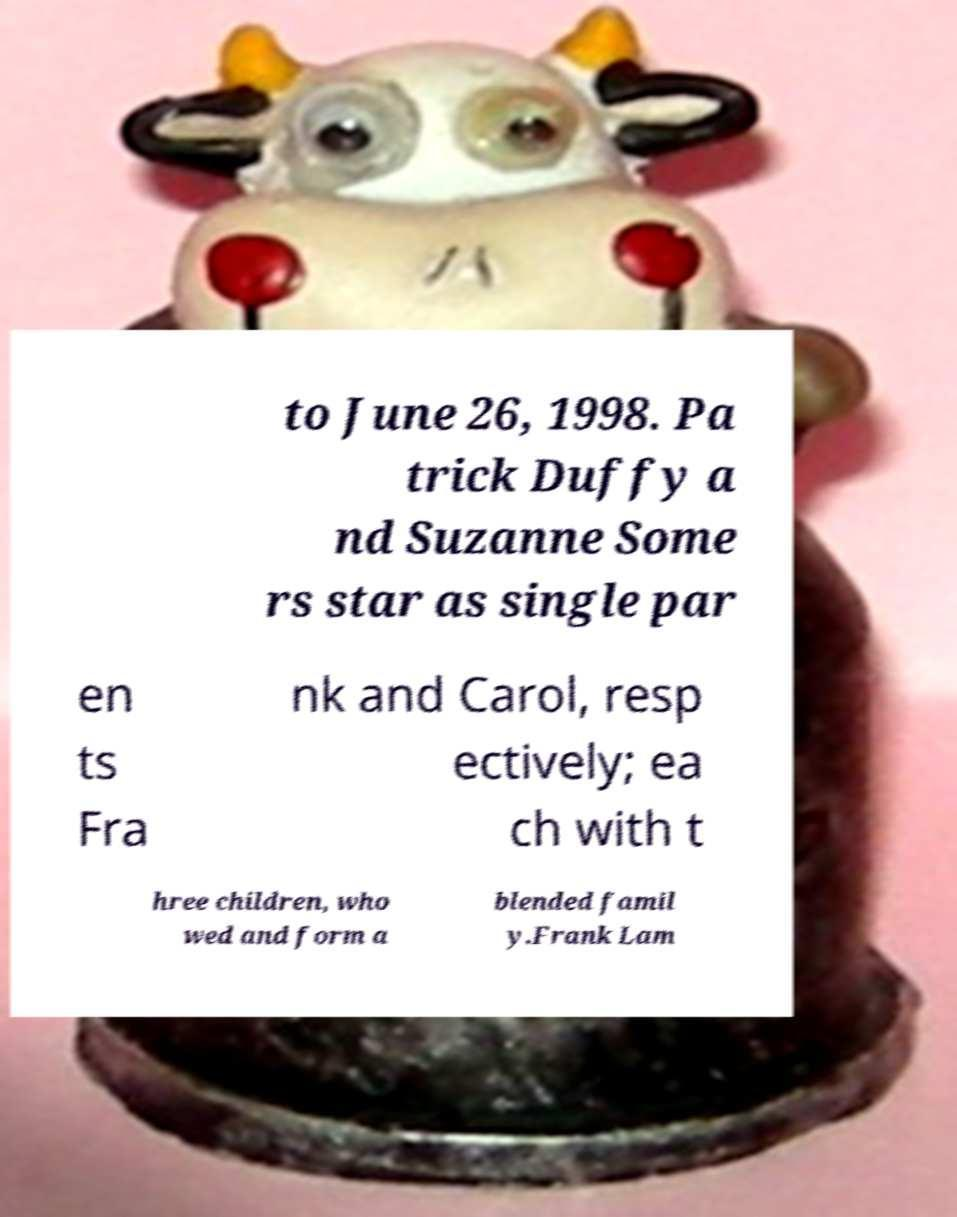There's text embedded in this image that I need extracted. Can you transcribe it verbatim? to June 26, 1998. Pa trick Duffy a nd Suzanne Some rs star as single par en ts Fra nk and Carol, resp ectively; ea ch with t hree children, who wed and form a blended famil y.Frank Lam 